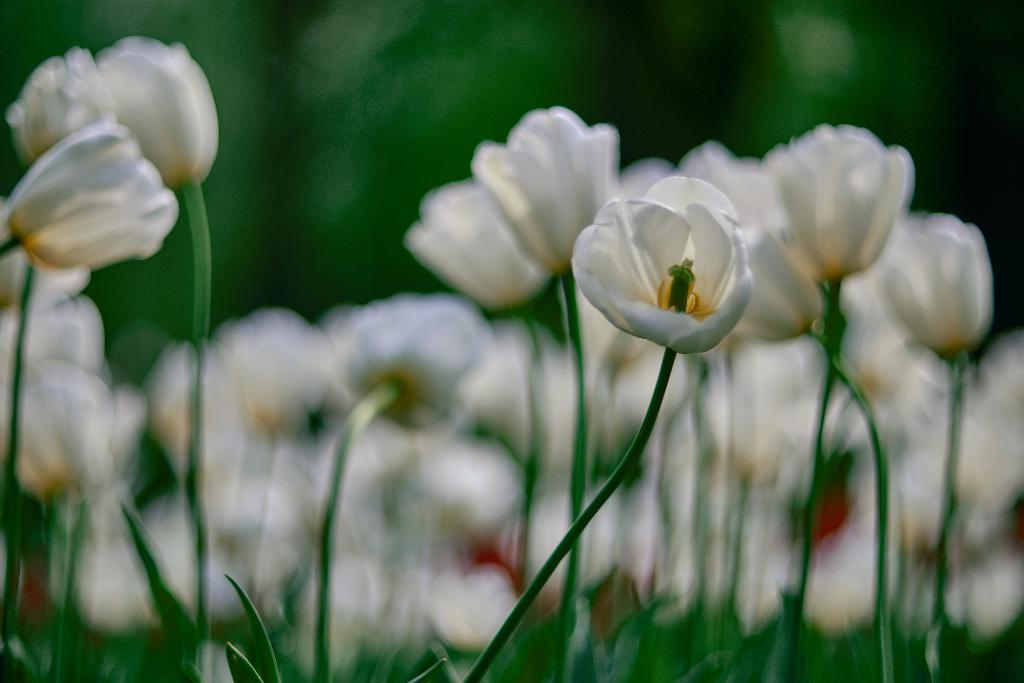What type of living organisms can be seen in the image? Plants can be seen in the image. What color are the flowers on the plants? The flowers on the plants are white. Can you describe the background of the image? The background of the image is blurred. What type of copper material can be seen in the image? There is no copper material present in the image. How are the plants being transported in the image? The plants are not being transported in the image; they are stationary. 